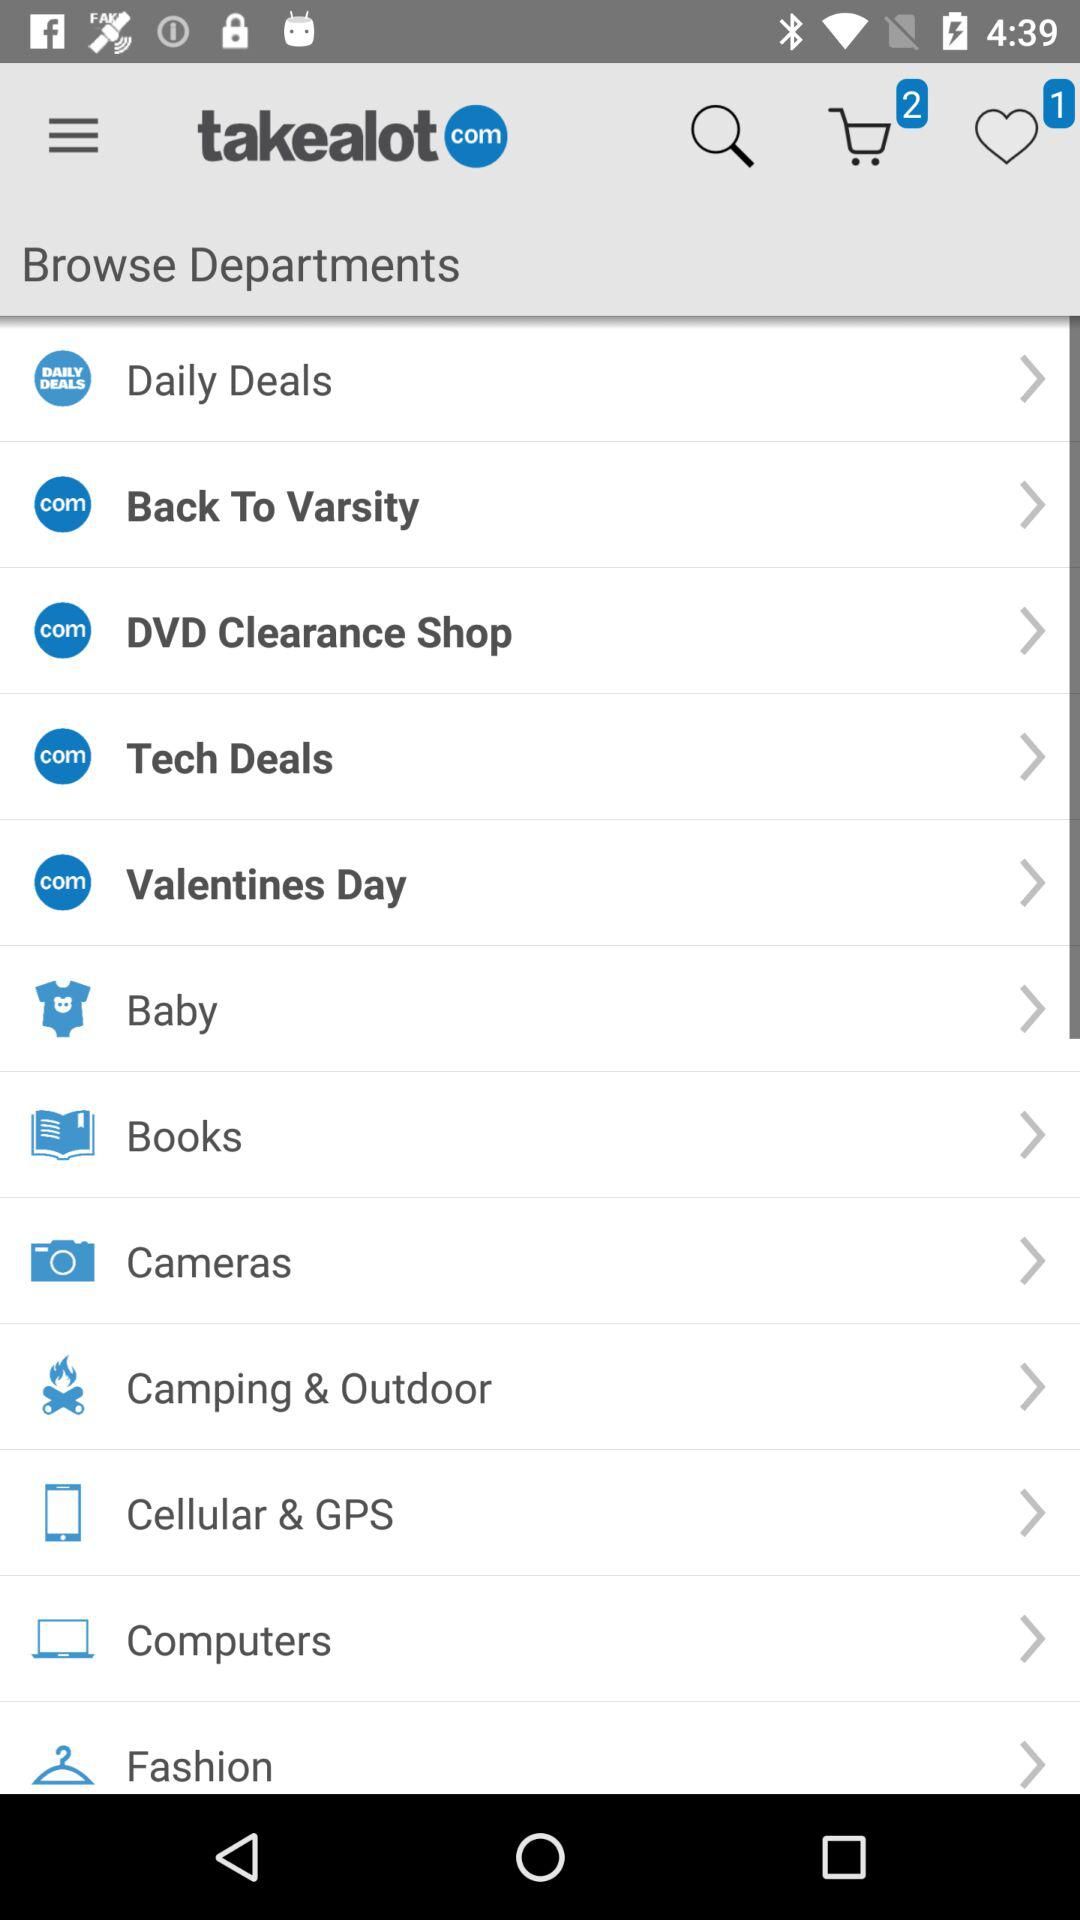How many items are added to the cart? The number of items added to the cart is 2. 